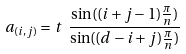<formula> <loc_0><loc_0><loc_500><loc_500>a _ { ( i , j ) } = t \ \frac { \sin ( ( i + j - 1 ) \frac { \pi } { n } ) } { \sin ( ( d - i + j ) \frac { \pi } { n } ) }</formula> 